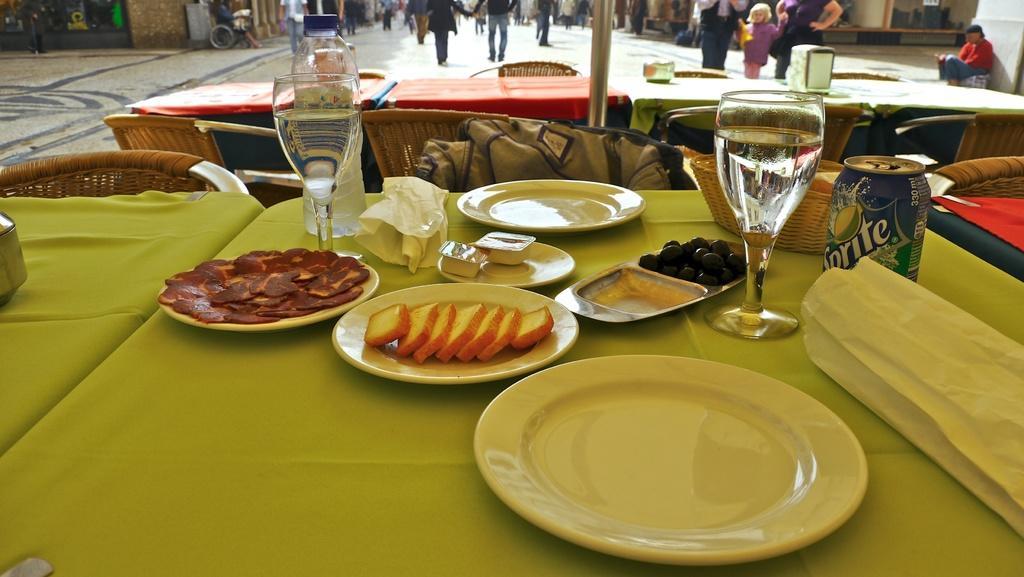In one or two sentences, can you explain what this image depicts? As we can see in the image there are chairs, tables, buildings and few people walking here and there. On tables there are plates, glasses, tin, basket and food items. 